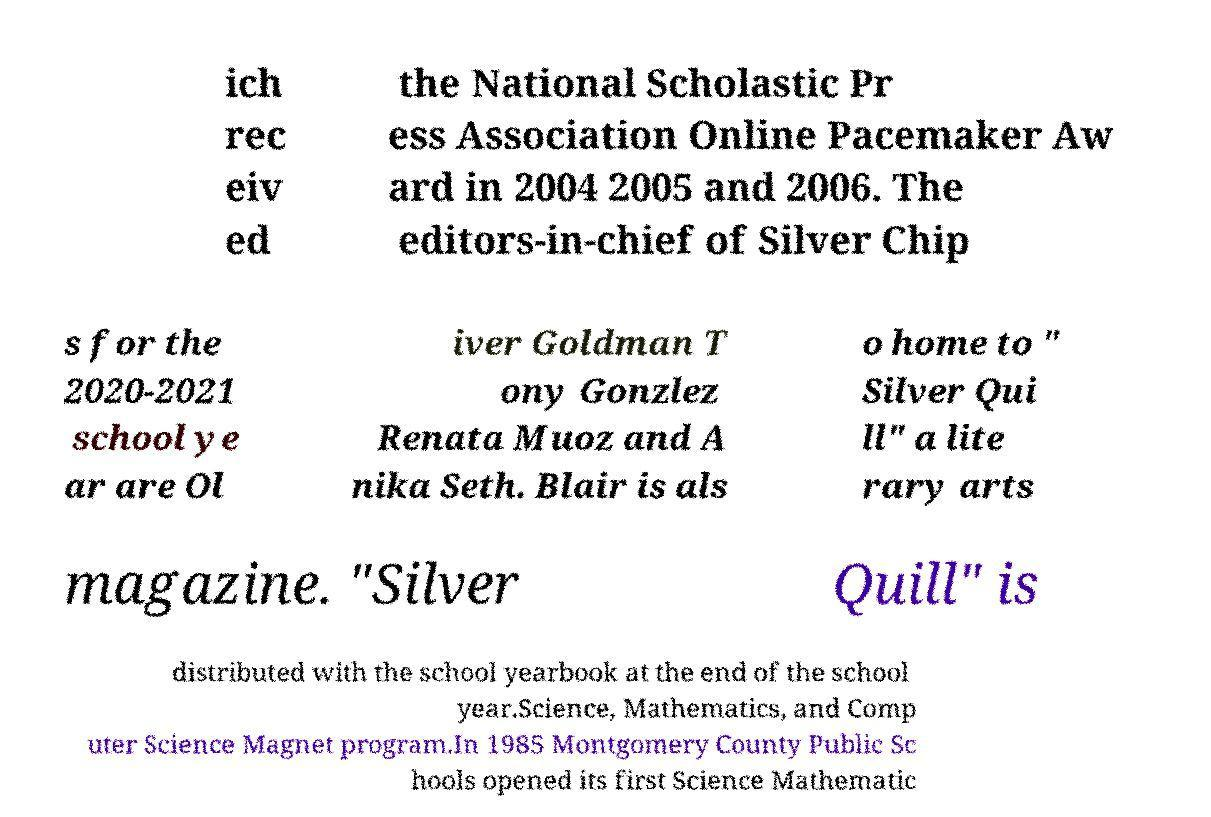There's text embedded in this image that I need extracted. Can you transcribe it verbatim? ich rec eiv ed the National Scholastic Pr ess Association Online Pacemaker Aw ard in 2004 2005 and 2006. The editors-in-chief of Silver Chip s for the 2020-2021 school ye ar are Ol iver Goldman T ony Gonzlez Renata Muoz and A nika Seth. Blair is als o home to " Silver Qui ll" a lite rary arts magazine. "Silver Quill" is distributed with the school yearbook at the end of the school year.Science, Mathematics, and Comp uter Science Magnet program.In 1985 Montgomery County Public Sc hools opened its first Science Mathematic 